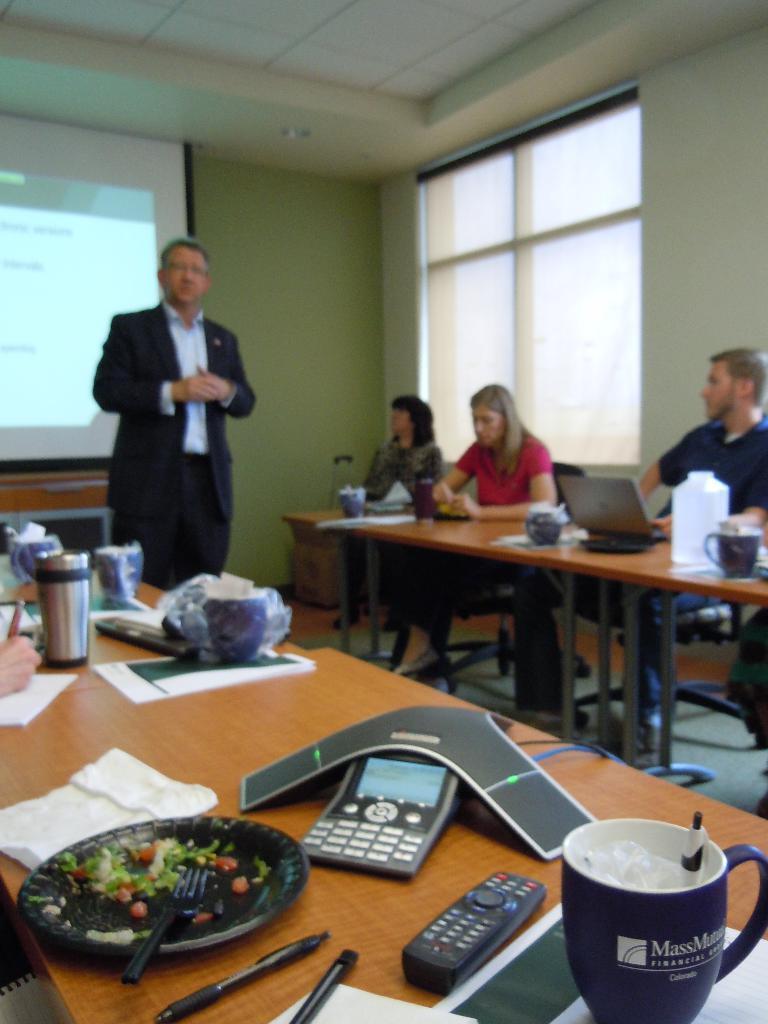How would you summarize this image in a sentence or two? In this picture I can see few people are sitting in the chairs and I can see plates, cups, water bottle and couple of laptops and I can see a remote and few napkins, papers, pens on the tables and I can see a man standing and a projector screen in the back. 